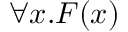Convert formula to latex. <formula><loc_0><loc_0><loc_500><loc_500>\forall x . F ( x )</formula> 